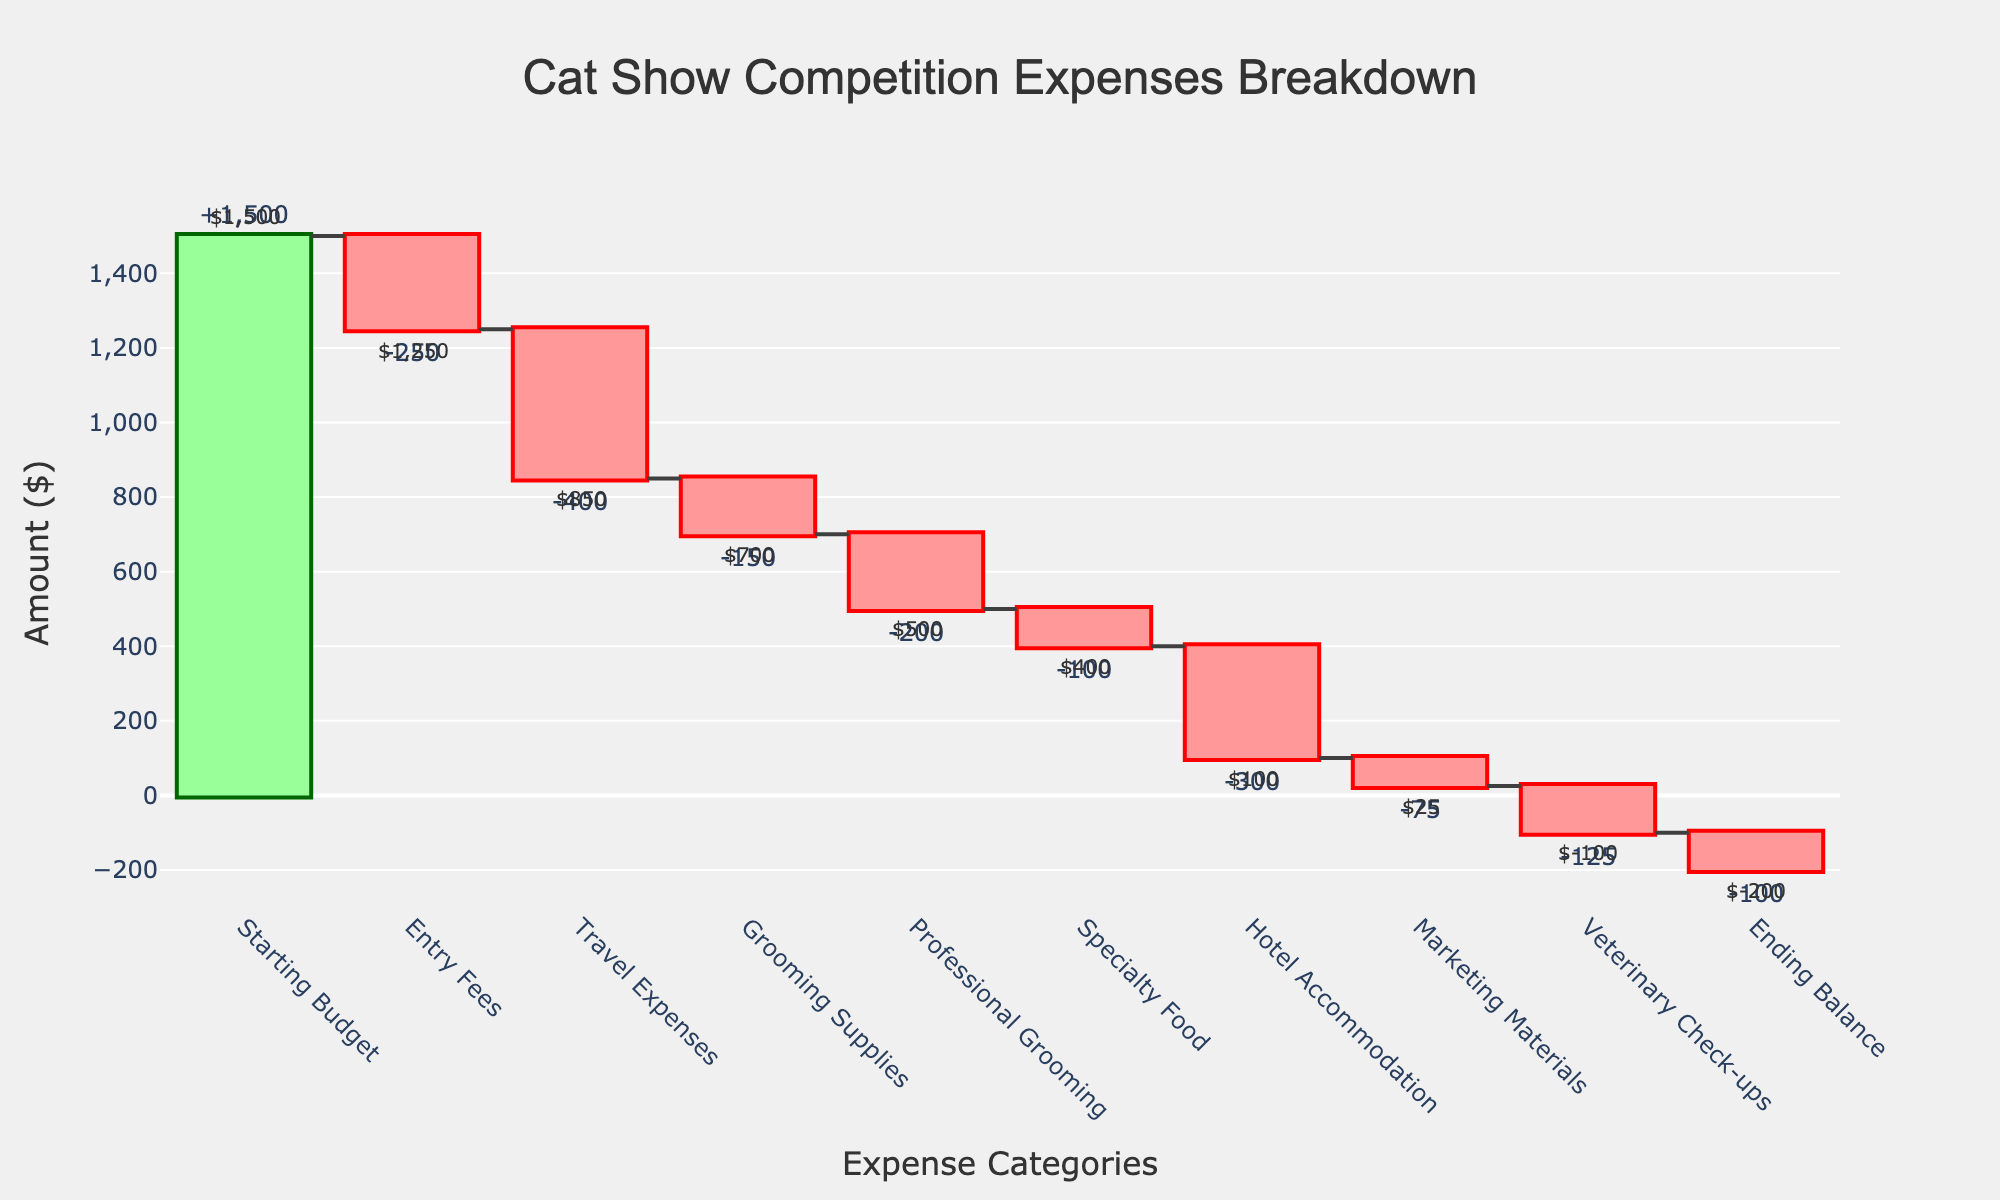What's the total amount spent on Grooming Supplies and Professional Grooming combined? Grooming Supplies cost $150 and Professional Grooming cost $200. Adding these together gives $150 + $200 = $350.
Answer: $350 Which category has the highest expense? The Travel Expenses category has the highest expense of $400, as visually indicated by the longest red bar.
Answer: Travel Expenses What's the ending balance after all expenses? According to the ending balance displayed in the figure, it is -$100, representing the final balance after deducting all expenses from the starting budget.
Answer: -$100 How much money is left after Travel Expenses but before deducting Grooming Supplies? Start with the total after deducting Travel Expenses ($1500 - $400 = $1100). This amount is before the next expense, Grooming Supplies.
Answer: $1100 Total amount spent on Entry Fees, Travel Expenses, and Hotel Accommodation? Entry Fees cost $250, Travel Expenses cost $400, and Hotel Accommodation costs $300. Adding these together gives $250 + $400 + $300 = $950.
Answer: $950 How do Marketing Materials compare to Specialty Food in terms of cost? Marketing Materials cost $75 and Specialty Food cost $100. Marketing Materials are $25 less expensive than Specialty Food.
Answer: Marketing Materials are $25 less What's the title of the figure? The title of the figure is "Cat Show Competition Expenses Breakdown," which is displayed at the top center of the chart.
Answer: Cat Show Competition Expenses Breakdown What is the starting budget? The starting budget is indicated clearly in the first bar of the figure, set at $1500.
Answer: $1500 